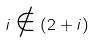Convert formula to latex. <formula><loc_0><loc_0><loc_500><loc_500>i \notin ( 2 + i )</formula> 